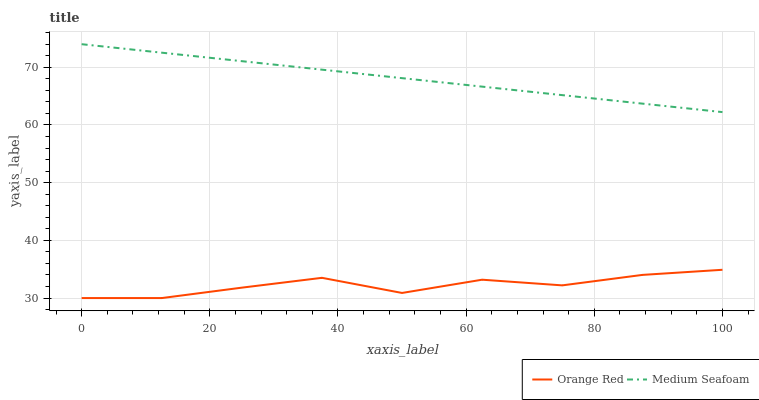Does Orange Red have the minimum area under the curve?
Answer yes or no. Yes. Does Medium Seafoam have the maximum area under the curve?
Answer yes or no. Yes. Does Medium Seafoam have the minimum area under the curve?
Answer yes or no. No. Is Medium Seafoam the smoothest?
Answer yes or no. Yes. Is Orange Red the roughest?
Answer yes or no. Yes. Is Medium Seafoam the roughest?
Answer yes or no. No. Does Orange Red have the lowest value?
Answer yes or no. Yes. Does Medium Seafoam have the lowest value?
Answer yes or no. No. Does Medium Seafoam have the highest value?
Answer yes or no. Yes. Is Orange Red less than Medium Seafoam?
Answer yes or no. Yes. Is Medium Seafoam greater than Orange Red?
Answer yes or no. Yes. Does Orange Red intersect Medium Seafoam?
Answer yes or no. No. 